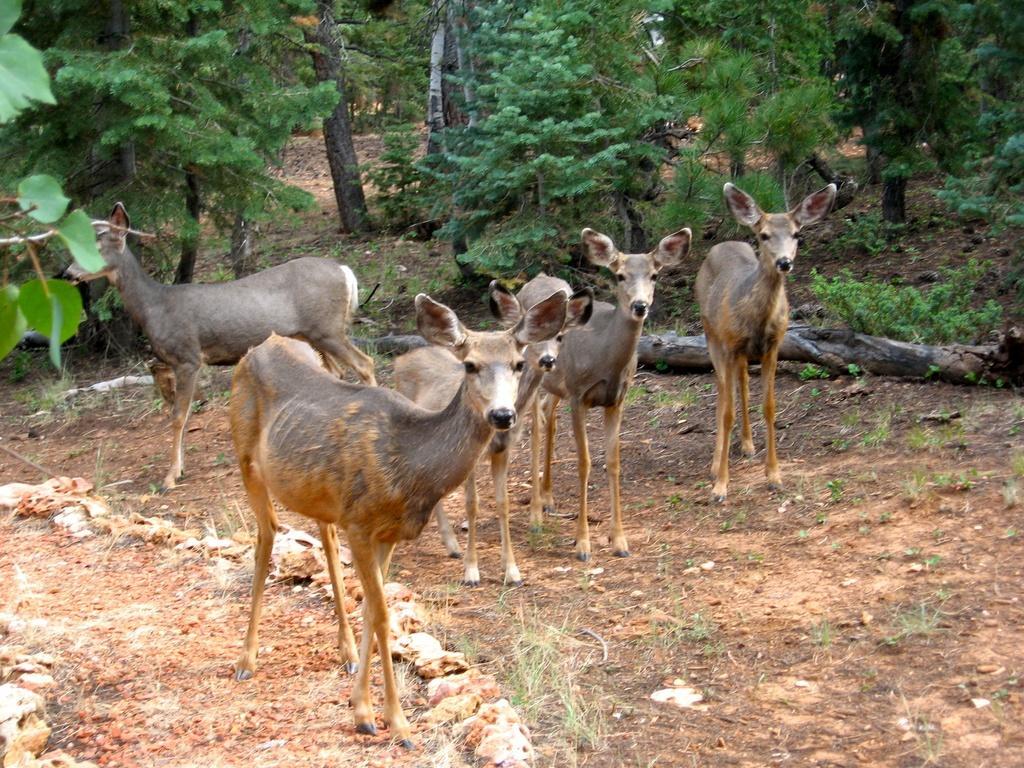In one or two sentences, can you explain what this image depicts? In this image we can see a herd standing on the ground. In the background there are trees and logs. 